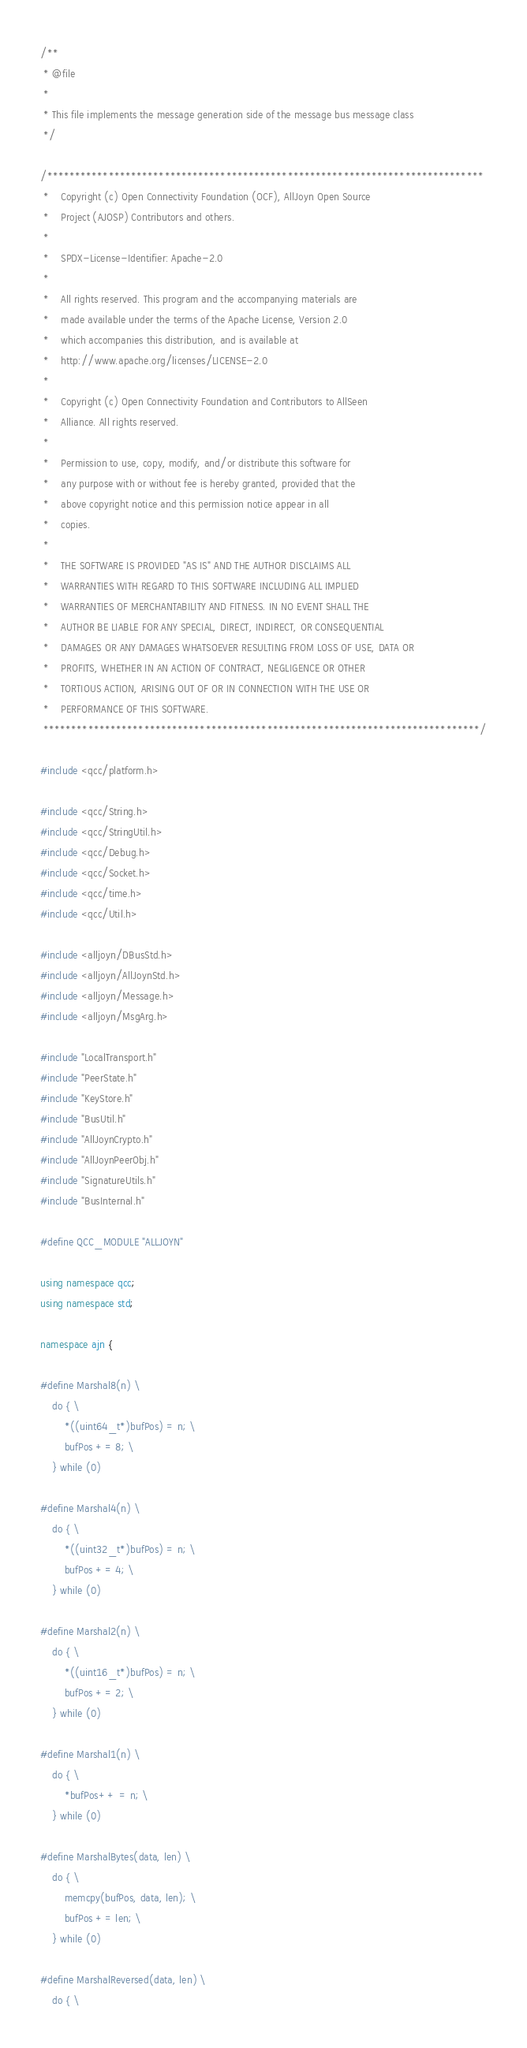<code> <loc_0><loc_0><loc_500><loc_500><_C++_>/**
 * @file
 *
 * This file implements the message generation side of the message bus message class
 */

/******************************************************************************
 *    Copyright (c) Open Connectivity Foundation (OCF), AllJoyn Open Source
 *    Project (AJOSP) Contributors and others.
 *
 *    SPDX-License-Identifier: Apache-2.0
 *
 *    All rights reserved. This program and the accompanying materials are
 *    made available under the terms of the Apache License, Version 2.0
 *    which accompanies this distribution, and is available at
 *    http://www.apache.org/licenses/LICENSE-2.0
 *
 *    Copyright (c) Open Connectivity Foundation and Contributors to AllSeen
 *    Alliance. All rights reserved.
 *
 *    Permission to use, copy, modify, and/or distribute this software for
 *    any purpose with or without fee is hereby granted, provided that the
 *    above copyright notice and this permission notice appear in all
 *    copies.
 *
 *    THE SOFTWARE IS PROVIDED "AS IS" AND THE AUTHOR DISCLAIMS ALL
 *    WARRANTIES WITH REGARD TO THIS SOFTWARE INCLUDING ALL IMPLIED
 *    WARRANTIES OF MERCHANTABILITY AND FITNESS. IN NO EVENT SHALL THE
 *    AUTHOR BE LIABLE FOR ANY SPECIAL, DIRECT, INDIRECT, OR CONSEQUENTIAL
 *    DAMAGES OR ANY DAMAGES WHATSOEVER RESULTING FROM LOSS OF USE, DATA OR
 *    PROFITS, WHETHER IN AN ACTION OF CONTRACT, NEGLIGENCE OR OTHER
 *    TORTIOUS ACTION, ARISING OUT OF OR IN CONNECTION WITH THE USE OR
 *    PERFORMANCE OF THIS SOFTWARE.
 ******************************************************************************/

#include <qcc/platform.h>

#include <qcc/String.h>
#include <qcc/StringUtil.h>
#include <qcc/Debug.h>
#include <qcc/Socket.h>
#include <qcc/time.h>
#include <qcc/Util.h>

#include <alljoyn/DBusStd.h>
#include <alljoyn/AllJoynStd.h>
#include <alljoyn/Message.h>
#include <alljoyn/MsgArg.h>

#include "LocalTransport.h"
#include "PeerState.h"
#include "KeyStore.h"
#include "BusUtil.h"
#include "AllJoynCrypto.h"
#include "AllJoynPeerObj.h"
#include "SignatureUtils.h"
#include "BusInternal.h"

#define QCC_MODULE "ALLJOYN"

using namespace qcc;
using namespace std;

namespace ajn {

#define Marshal8(n) \
    do { \
        *((uint64_t*)bufPos) = n; \
        bufPos += 8; \
    } while (0)

#define Marshal4(n) \
    do { \
        *((uint32_t*)bufPos) = n; \
        bufPos += 4; \
    } while (0)

#define Marshal2(n) \
    do { \
        *((uint16_t*)bufPos) = n; \
        bufPos += 2; \
    } while (0)

#define Marshal1(n) \
    do { \
        *bufPos++ = n; \
    } while (0)

#define MarshalBytes(data, len) \
    do { \
        memcpy(bufPos, data, len); \
        bufPos += len; \
    } while (0)

#define MarshalReversed(data, len) \
    do { \</code> 